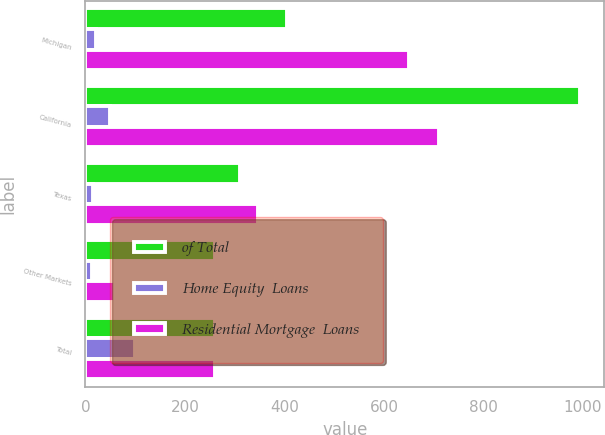Convert chart. <chart><loc_0><loc_0><loc_500><loc_500><stacked_bar_chart><ecel><fcel>Michigan<fcel>California<fcel>Texas<fcel>Other Markets<fcel>Total<nl><fcel>of Total<fcel>406<fcel>993<fcel>310<fcel>261<fcel>261<nl><fcel>Home Equity  Loans<fcel>21<fcel>50<fcel>16<fcel>13<fcel>100<nl><fcel>Residential Mortgage  Loans<fcel>650<fcel>710<fcel>346<fcel>59<fcel>261<nl></chart> 